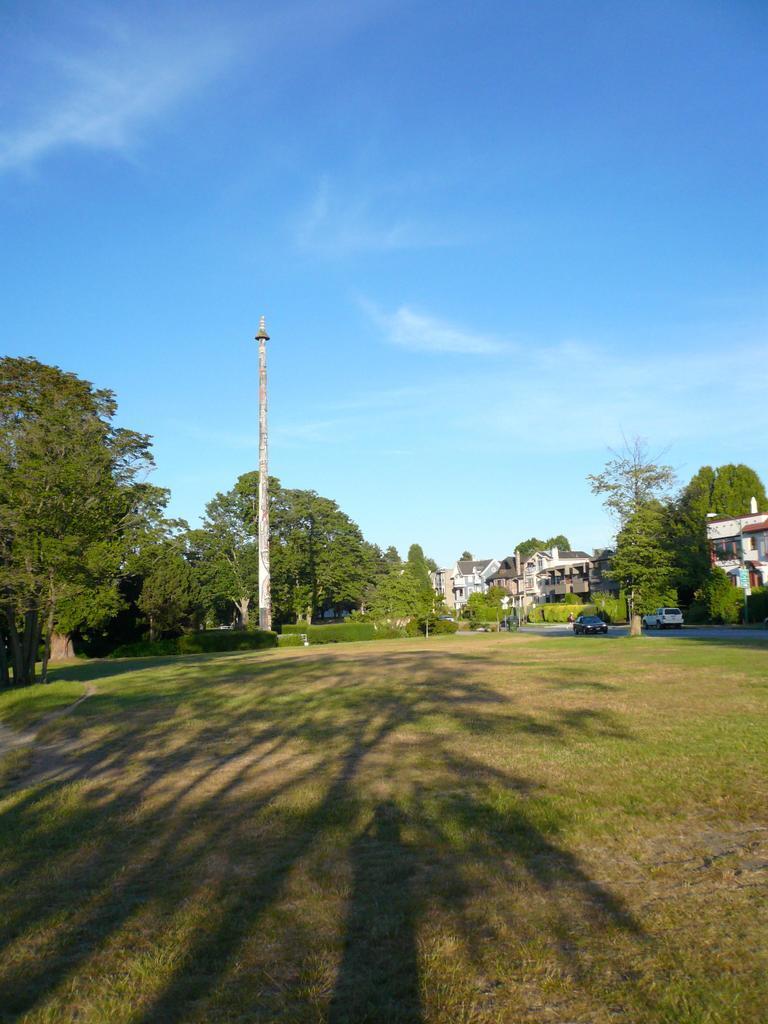Could you give a brief overview of what you see in this image? In the picture I can see the houses and trees. I can see two cars on the road. In the foreground I can see the green grass. There are clouds in the sky. I can see a pole on the left side. 